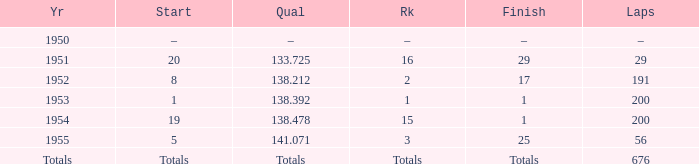What is the start of the race with 676 laps? Totals. 